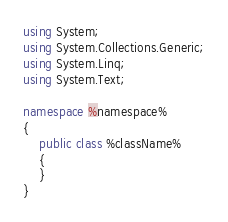<code> <loc_0><loc_0><loc_500><loc_500><_C#_>using System;
using System.Collections.Generic;
using System.Linq;
using System.Text;

namespace %namespace%
{
    public class %className%
    {
    }
}</code> 